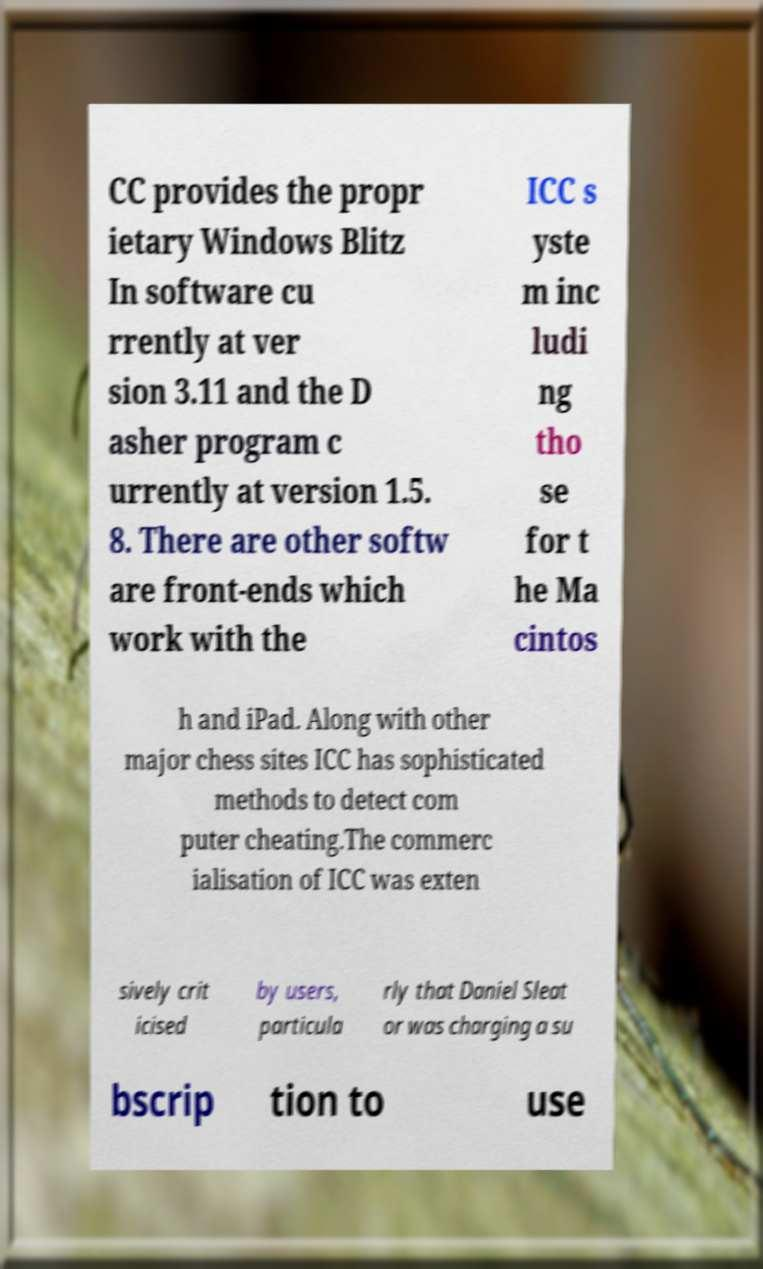Please identify and transcribe the text found in this image. CC provides the propr ietary Windows Blitz In software cu rrently at ver sion 3.11 and the D asher program c urrently at version 1.5. 8. There are other softw are front-ends which work with the ICC s yste m inc ludi ng tho se for t he Ma cintos h and iPad. Along with other major chess sites ICC has sophisticated methods to detect com puter cheating.The commerc ialisation of ICC was exten sively crit icised by users, particula rly that Daniel Sleat or was charging a su bscrip tion to use 